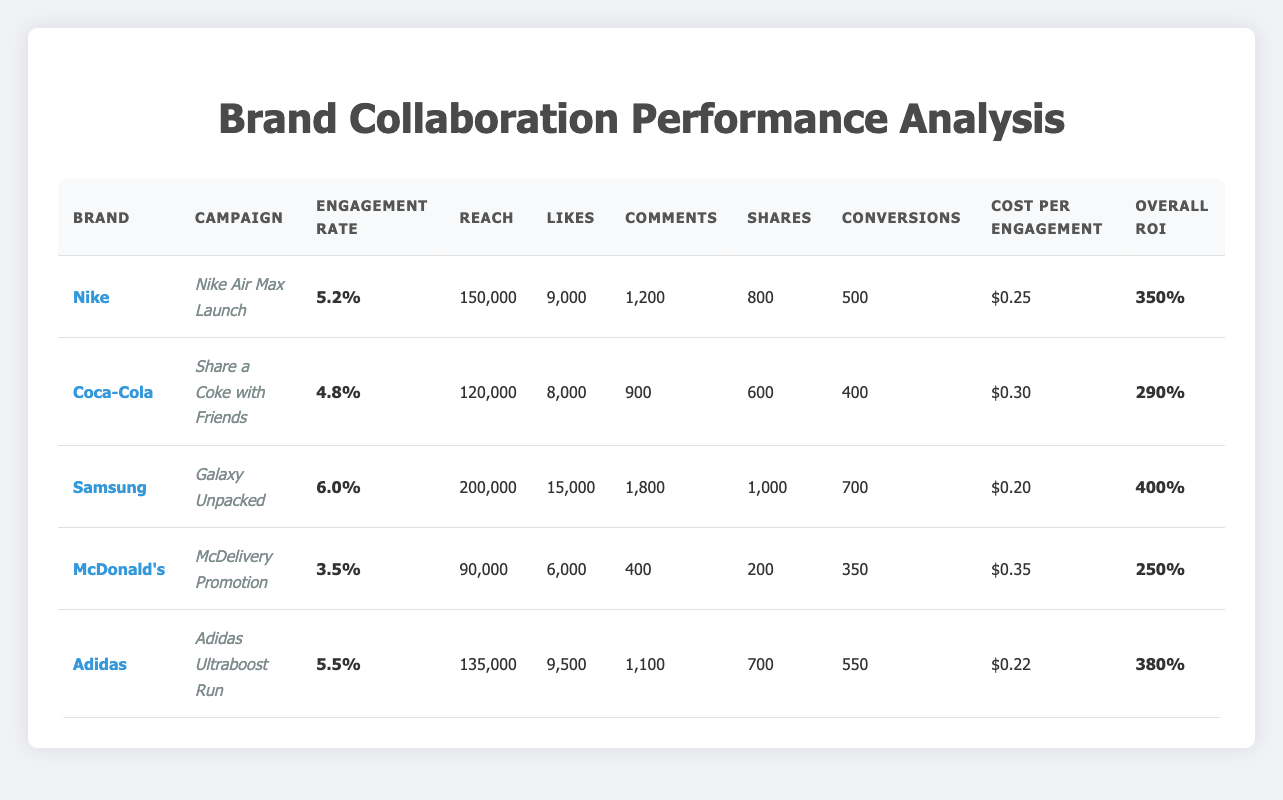What is the engagement rate for the Coca-Cola campaign? The table lists the engagement rate for each campaign. For Coca-Cola's "Share a Coke with Friends," the engagement rate is shown as 4.8.
Answer: 4.8 Which brand had the highest number of conversions? The table provides the conversions for each brand's campaign. Samsung's "Galaxy Unpacked" had the highest number of conversions with a total of 700.
Answer: Samsung What is the cost per engagement for the Adidas campaign? According to the table, the cost per engagement for the Adidas campaign "Adidas Ultraboost Run" is 0.22.
Answer: 0.22 Is it true that McDonald's campaign had an engagement rate above 4.0? The engagement rate for McDonald's "McDelivery Promotion" is listed as 3.5 in the table, which is below 4.0. Thus, the statement is false.
Answer: No What is the average engagement rate across all the campaigns listed? To calculate the average engagement rate, sum the engagement rates (5.2 + 4.8 + 6.0 + 3.5 + 5.5 = 25.0) and then divide by the number of campaigns (5). The average engagement rate is 25.0 / 5 = 5.0.
Answer: 5.0 Which brand had the lowest overall ROI? The overall ROI for each brand is displayed in the table. McDonald's "McDelivery Promotion" has the lowest overall ROI of 2.5 compared to the others.
Answer: McDonald's How many more likes did Samsung receive than Coca-Cola? The table states that Samsung's likes are 15,000 and Coca-Cola's likes are 8,000. The difference (15,000 - 8,000) equals 7,000, indicating that Samsung received 7,000 more likes than Coca-Cola.
Answer: 7,000 Does the Nike campaign have a higher engagement rate than the Adidas campaign? Nike's engagement rate is 5.2, while Adidas' engagement rate is 5.5. Since 5.2 is less than 5.5, the statement is false.
Answer: No What is the total reach of the campaigns for Nike and Adidas combined? From the table, the reach for Nike is 150,000 and Adidas is 135,000. Adding these values gives 150,000 + 135,000 = 285,000, which is the total reach for the two campaigns.
Answer: 285,000 